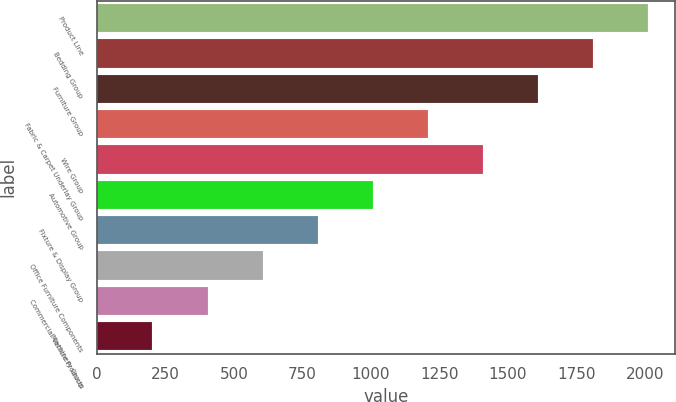Convert chart. <chart><loc_0><loc_0><loc_500><loc_500><bar_chart><fcel>Product Line<fcel>Bedding Group<fcel>Furniture Group<fcel>Fabric & Carpet Underlay Group<fcel>Wire Group<fcel>Automotive Group<fcel>Fixture & Display Group<fcel>Office Furniture Components<fcel>Commercial Vehicle Products<fcel>Machinery Group<nl><fcel>2011<fcel>1810.1<fcel>1609.2<fcel>1207.4<fcel>1408.3<fcel>1006.5<fcel>805.6<fcel>604.7<fcel>403.8<fcel>202.9<nl></chart> 